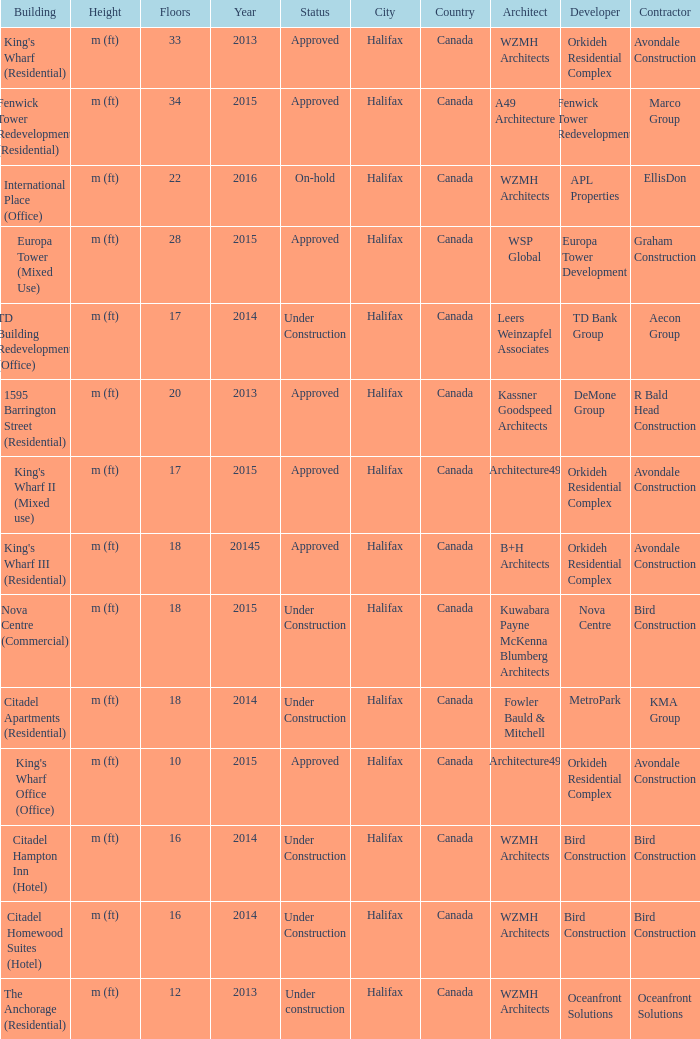What is the status of the building with more than 28 floor and a year of 2013? Approved. 